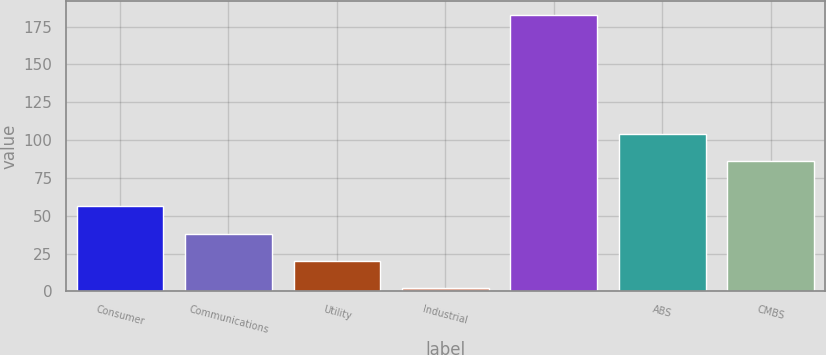Convert chart to OTSL. <chart><loc_0><loc_0><loc_500><loc_500><bar_chart><fcel>Consumer<fcel>Communications<fcel>Utility<fcel>Industrial<fcel>Unnamed: 4<fcel>ABS<fcel>CMBS<nl><fcel>56.3<fcel>38.2<fcel>20.1<fcel>2<fcel>183<fcel>104.1<fcel>86<nl></chart> 